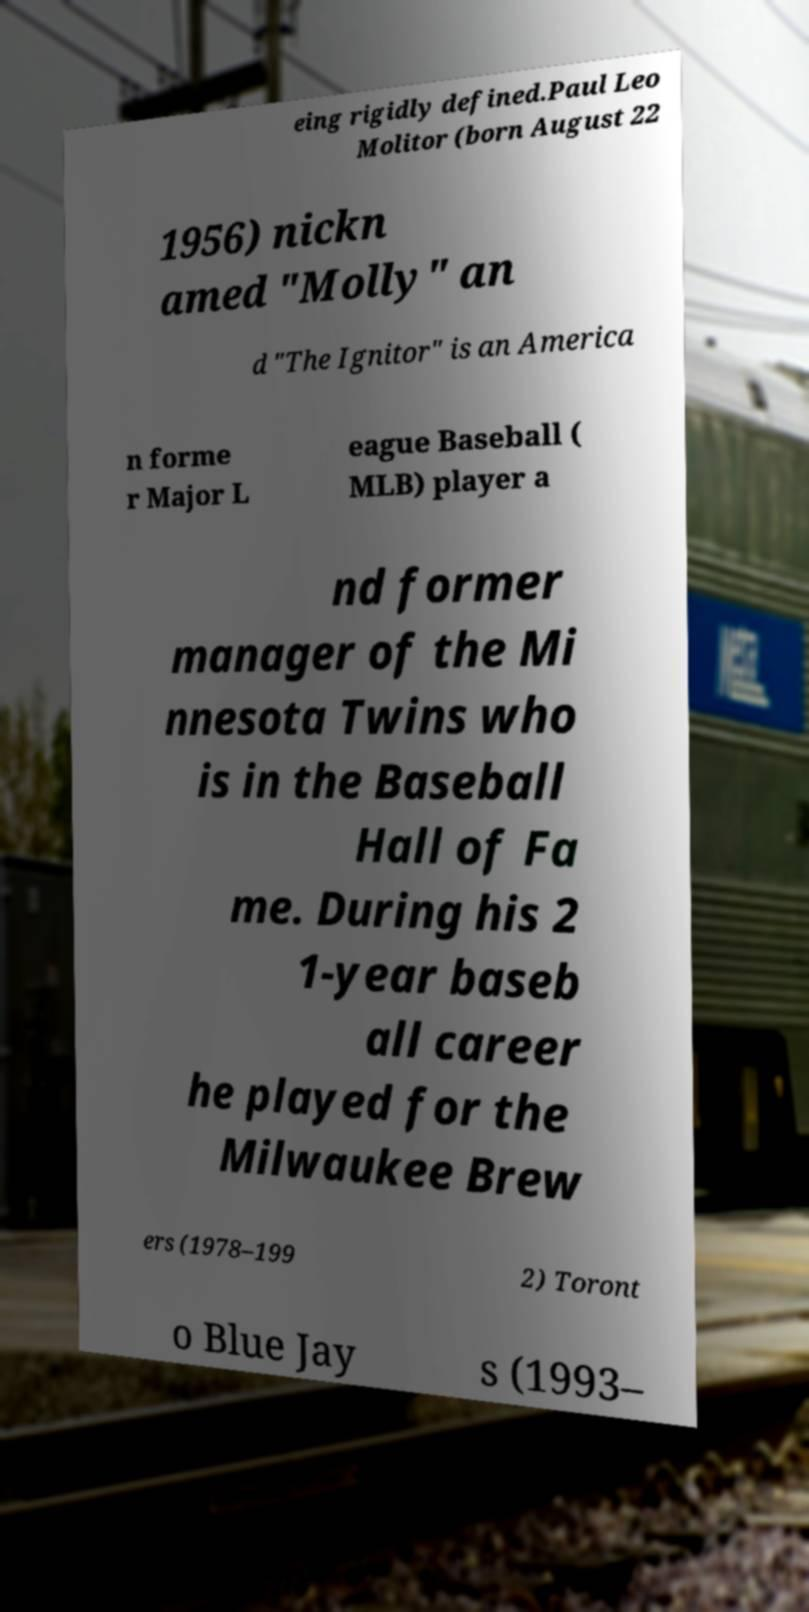Could you extract and type out the text from this image? eing rigidly defined.Paul Leo Molitor (born August 22 1956) nickn amed "Molly" an d "The Ignitor" is an America n forme r Major L eague Baseball ( MLB) player a nd former manager of the Mi nnesota Twins who is in the Baseball Hall of Fa me. During his 2 1-year baseb all career he played for the Milwaukee Brew ers (1978–199 2) Toront o Blue Jay s (1993– 